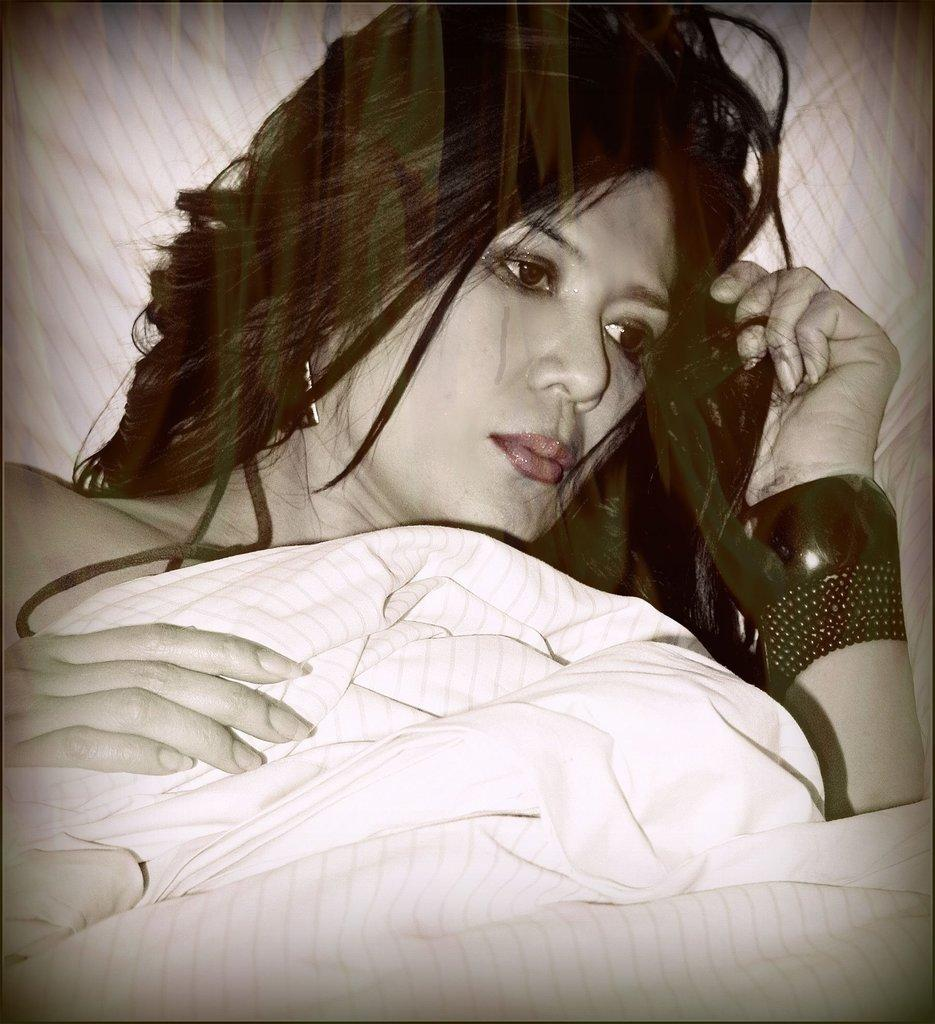Who is the main subject in the image? There is a woman in the image. What is the woman doing in the image? The woman is lying on a bed. What is covering the woman in the image? The woman is covered by a bed sheet. What type of operation is the woman undergoing in the image? There is no indication of an operation in the image; the woman is simply lying on a bed covered by a bed sheet. 